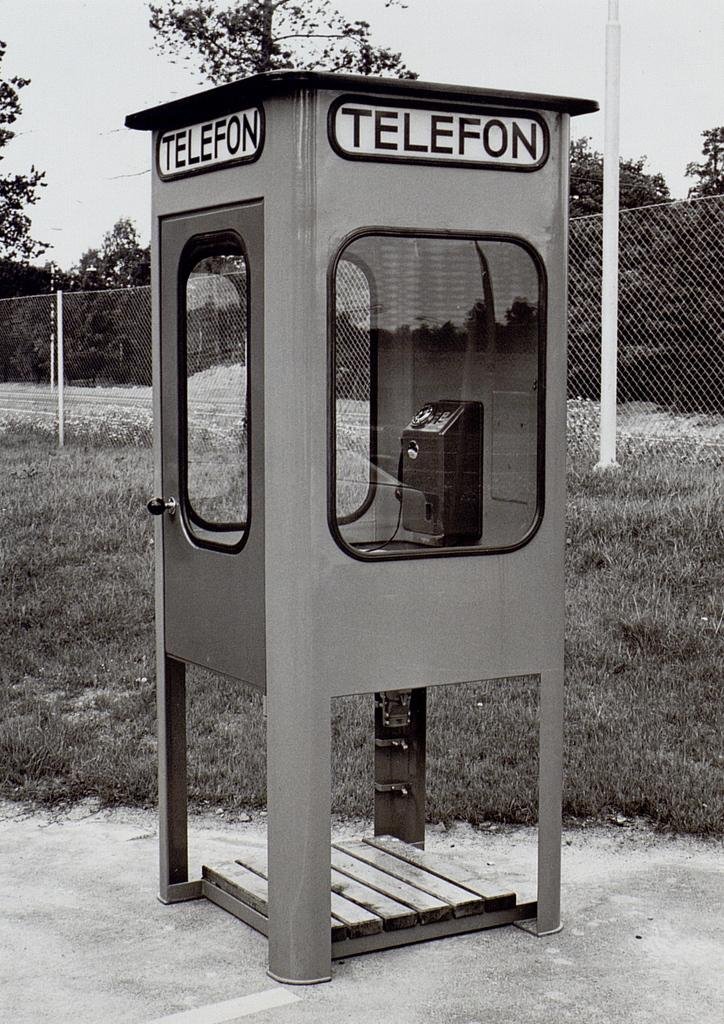<image>
Render a clear and concise summary of the photo. A gray phone booth has the word telefon on the top side of it. 